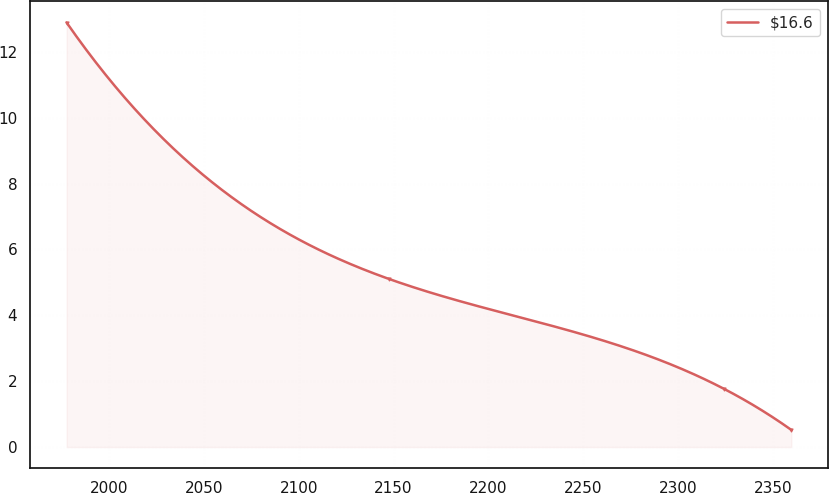<chart> <loc_0><loc_0><loc_500><loc_500><line_chart><ecel><fcel>$16.6<nl><fcel>1977.65<fcel>12.89<nl><fcel>2147.8<fcel>5.1<nl><fcel>2324.45<fcel>1.76<nl><fcel>2359.7<fcel>0.52<nl></chart> 